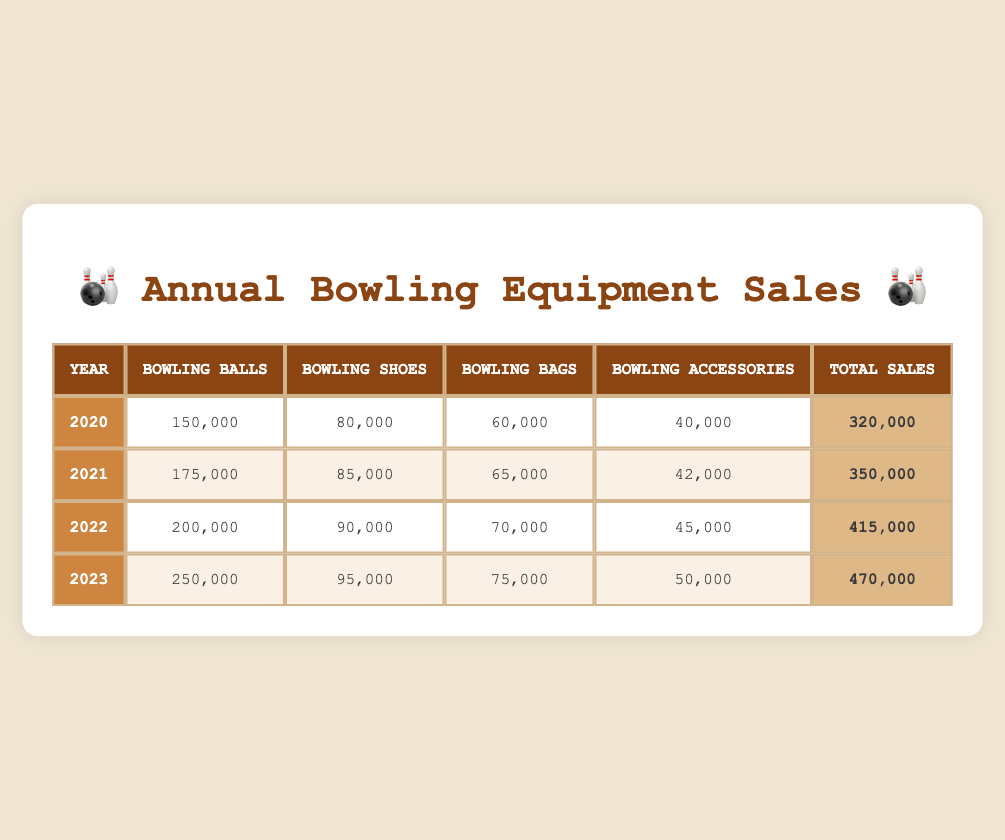What was the total sales in 2021? To find the total sales for 2021, refer to the Total Sales column for the year 2021, which shows the value of 350,000.
Answer: 350,000 How many Bowling Balls were sold in 2022? The number of Bowling Balls sold in 2022 can be found in the Bowling Balls column for that year, which shows 200,000.
Answer: 200,000 What category had the least sales in 2020? In 2020, the Bowling Accessories category had the least sales, with a total of 40,000 compared to other categories.
Answer: Bowling Accessories What is the difference in Total Sales between 2020 and 2023? The Total Sales in 2020 is 320,000, and in 2023 it is 470,000. The difference can be calculated as 470,000 - 320,000 = 150,000.
Answer: 150,000 What is the average number of Bowling Shoes sold from 2020 to 2023? To find the average, sum the Bowling Shoes sold over the years: 80,000 + 85,000 + 90,000 + 95,000 = 350,000. Since there are 4 years, divide by 4 to get the average: 350,000 / 4 = 87,500.
Answer: 87,500 Did the sales of Bowling Bags increase every year from 2020 to 2023? By checking the Bowling Bags column, we see the values are 60,000 (2020), 65,000 (2021), 70,000 (2022), and 75,000 (2023). Since the values are consistently increasing each year, the answer is yes.
Answer: Yes What percentage of total sales in 2023 came from Bowling Balls? In 2023, Bowling Balls sales were 250,000 and total sales were 470,000. The percentage is (250,000 / 470,000) * 100 = 53.19%. So, Bowling Balls made up about 53.19% of the total sales that year.
Answer: 53.19% What was the total sales across all categories in 2022? The total sales figure for 2022 is found in the Total Sales column for that year, which is 415,000.
Answer: 415,000 In which year was the sale of Bowling Accessories the highest? By examining the Bowling Accessories column, the sales were 40,000 (2020), 42,000 (2021), 45,000 (2022), and 50,000 (2023). The highest value is 50,000 in 2023.
Answer: 2023 What was the total sales growth from 2020 to 2022? To find the growth from 2020 (320,000) to 2022 (415,000), calculate the difference: 415,000 - 320,000 = 95,000. Hence, the total sales growth is 95,000.
Answer: 95,000 